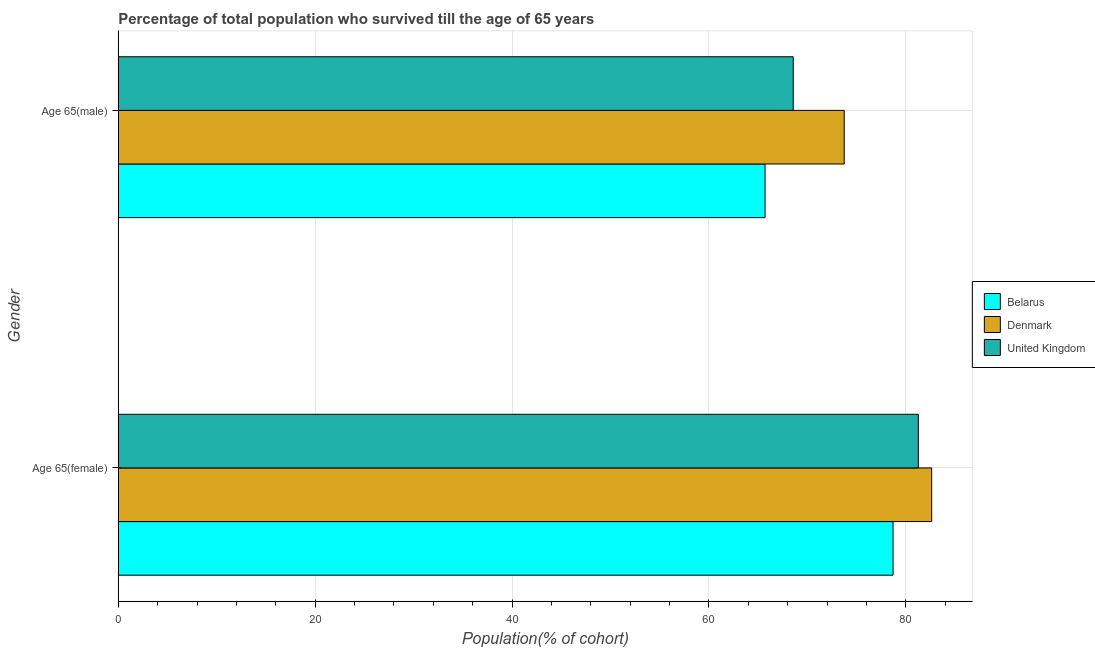How many different coloured bars are there?
Offer a very short reply. 3. How many groups of bars are there?
Your answer should be very brief. 2. Are the number of bars on each tick of the Y-axis equal?
Offer a very short reply. Yes. How many bars are there on the 2nd tick from the top?
Offer a terse response. 3. What is the label of the 2nd group of bars from the top?
Offer a very short reply. Age 65(female). What is the percentage of female population who survived till age of 65 in Denmark?
Your response must be concise. 82.63. Across all countries, what is the maximum percentage of female population who survived till age of 65?
Your response must be concise. 82.63. Across all countries, what is the minimum percentage of female population who survived till age of 65?
Offer a terse response. 78.71. In which country was the percentage of male population who survived till age of 65 maximum?
Offer a terse response. Denmark. In which country was the percentage of male population who survived till age of 65 minimum?
Your response must be concise. Belarus. What is the total percentage of male population who survived till age of 65 in the graph?
Give a very brief answer. 208.02. What is the difference between the percentage of male population who survived till age of 65 in Belarus and that in Denmark?
Ensure brevity in your answer.  -8.04. What is the difference between the percentage of male population who survived till age of 65 in Belarus and the percentage of female population who survived till age of 65 in United Kingdom?
Keep it short and to the point. -15.57. What is the average percentage of male population who survived till age of 65 per country?
Your answer should be very brief. 69.34. What is the difference between the percentage of female population who survived till age of 65 and percentage of male population who survived till age of 65 in United Kingdom?
Ensure brevity in your answer.  12.71. In how many countries, is the percentage of female population who survived till age of 65 greater than 12 %?
Offer a very short reply. 3. What is the ratio of the percentage of female population who survived till age of 65 in Denmark to that in United Kingdom?
Provide a short and direct response. 1.02. Is the percentage of female population who survived till age of 65 in Belarus less than that in United Kingdom?
Make the answer very short. Yes. In how many countries, is the percentage of male population who survived till age of 65 greater than the average percentage of male population who survived till age of 65 taken over all countries?
Offer a terse response. 1. What does the 1st bar from the top in Age 65(male) represents?
Keep it short and to the point. United Kingdom. Are all the bars in the graph horizontal?
Offer a very short reply. Yes. What is the difference between two consecutive major ticks on the X-axis?
Give a very brief answer. 20. Does the graph contain any zero values?
Provide a succinct answer. No. Where does the legend appear in the graph?
Offer a very short reply. Center right. How many legend labels are there?
Your answer should be very brief. 3. What is the title of the graph?
Provide a succinct answer. Percentage of total population who survived till the age of 65 years. What is the label or title of the X-axis?
Your response must be concise. Population(% of cohort). What is the label or title of the Y-axis?
Your response must be concise. Gender. What is the Population(% of cohort) in Belarus in Age 65(female)?
Provide a short and direct response. 78.71. What is the Population(% of cohort) in Denmark in Age 65(female)?
Offer a terse response. 82.63. What is the Population(% of cohort) in United Kingdom in Age 65(female)?
Provide a short and direct response. 81.28. What is the Population(% of cohort) in Belarus in Age 65(male)?
Give a very brief answer. 65.7. What is the Population(% of cohort) of Denmark in Age 65(male)?
Provide a short and direct response. 73.75. What is the Population(% of cohort) of United Kingdom in Age 65(male)?
Provide a succinct answer. 68.57. Across all Gender, what is the maximum Population(% of cohort) of Belarus?
Make the answer very short. 78.71. Across all Gender, what is the maximum Population(% of cohort) of Denmark?
Give a very brief answer. 82.63. Across all Gender, what is the maximum Population(% of cohort) in United Kingdom?
Ensure brevity in your answer.  81.28. Across all Gender, what is the minimum Population(% of cohort) in Belarus?
Give a very brief answer. 65.7. Across all Gender, what is the minimum Population(% of cohort) of Denmark?
Your response must be concise. 73.75. Across all Gender, what is the minimum Population(% of cohort) of United Kingdom?
Ensure brevity in your answer.  68.57. What is the total Population(% of cohort) in Belarus in the graph?
Your response must be concise. 144.41. What is the total Population(% of cohort) in Denmark in the graph?
Your answer should be very brief. 156.38. What is the total Population(% of cohort) in United Kingdom in the graph?
Provide a succinct answer. 149.84. What is the difference between the Population(% of cohort) of Belarus in Age 65(female) and that in Age 65(male)?
Your answer should be very brief. 13. What is the difference between the Population(% of cohort) of Denmark in Age 65(female) and that in Age 65(male)?
Your answer should be very brief. 8.88. What is the difference between the Population(% of cohort) of United Kingdom in Age 65(female) and that in Age 65(male)?
Your answer should be compact. 12.71. What is the difference between the Population(% of cohort) in Belarus in Age 65(female) and the Population(% of cohort) in Denmark in Age 65(male)?
Make the answer very short. 4.96. What is the difference between the Population(% of cohort) in Belarus in Age 65(female) and the Population(% of cohort) in United Kingdom in Age 65(male)?
Your response must be concise. 10.14. What is the difference between the Population(% of cohort) in Denmark in Age 65(female) and the Population(% of cohort) in United Kingdom in Age 65(male)?
Provide a succinct answer. 14.06. What is the average Population(% of cohort) of Belarus per Gender?
Your answer should be very brief. 72.21. What is the average Population(% of cohort) of Denmark per Gender?
Offer a very short reply. 78.19. What is the average Population(% of cohort) of United Kingdom per Gender?
Offer a terse response. 74.92. What is the difference between the Population(% of cohort) in Belarus and Population(% of cohort) in Denmark in Age 65(female)?
Offer a terse response. -3.92. What is the difference between the Population(% of cohort) of Belarus and Population(% of cohort) of United Kingdom in Age 65(female)?
Give a very brief answer. -2.57. What is the difference between the Population(% of cohort) in Denmark and Population(% of cohort) in United Kingdom in Age 65(female)?
Your answer should be very brief. 1.36. What is the difference between the Population(% of cohort) in Belarus and Population(% of cohort) in Denmark in Age 65(male)?
Provide a succinct answer. -8.04. What is the difference between the Population(% of cohort) in Belarus and Population(% of cohort) in United Kingdom in Age 65(male)?
Your answer should be very brief. -2.86. What is the difference between the Population(% of cohort) of Denmark and Population(% of cohort) of United Kingdom in Age 65(male)?
Your answer should be very brief. 5.18. What is the ratio of the Population(% of cohort) in Belarus in Age 65(female) to that in Age 65(male)?
Give a very brief answer. 1.2. What is the ratio of the Population(% of cohort) of Denmark in Age 65(female) to that in Age 65(male)?
Make the answer very short. 1.12. What is the ratio of the Population(% of cohort) of United Kingdom in Age 65(female) to that in Age 65(male)?
Offer a terse response. 1.19. What is the difference between the highest and the second highest Population(% of cohort) in Belarus?
Your response must be concise. 13. What is the difference between the highest and the second highest Population(% of cohort) in Denmark?
Give a very brief answer. 8.88. What is the difference between the highest and the second highest Population(% of cohort) of United Kingdom?
Offer a very short reply. 12.71. What is the difference between the highest and the lowest Population(% of cohort) in Belarus?
Offer a very short reply. 13. What is the difference between the highest and the lowest Population(% of cohort) of Denmark?
Ensure brevity in your answer.  8.88. What is the difference between the highest and the lowest Population(% of cohort) in United Kingdom?
Provide a short and direct response. 12.71. 